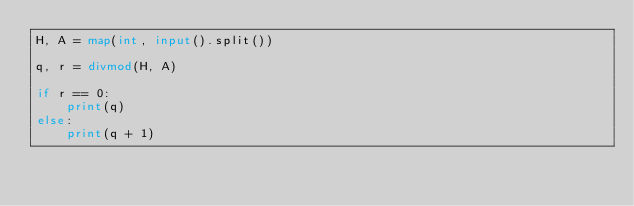<code> <loc_0><loc_0><loc_500><loc_500><_Python_>H, A = map(int, input().split())

q, r = divmod(H, A)

if r == 0:
    print(q)
else:
    print(q + 1)

</code> 